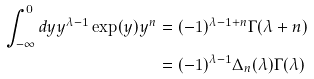Convert formula to latex. <formula><loc_0><loc_0><loc_500><loc_500>\int _ { - \infty } ^ { 0 } d y y ^ { \lambda - 1 } \exp ( y ) y ^ { n } & = ( - 1 ) ^ { \lambda - 1 + n } \Gamma ( \lambda + n ) \\ & = ( - 1 ) ^ { \lambda - 1 } \Delta _ { n } ( \lambda ) \Gamma ( \lambda )</formula> 